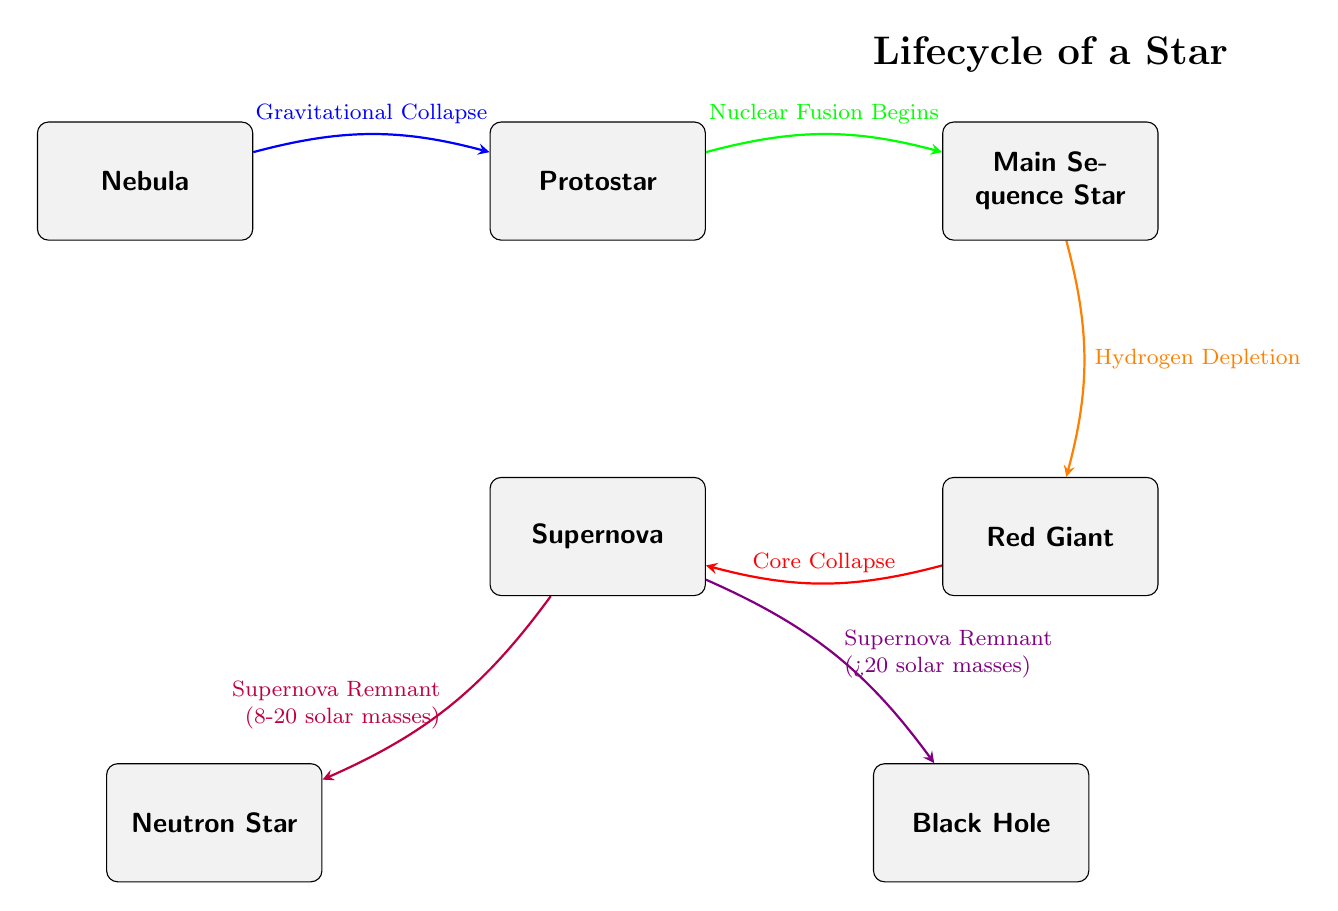What is the first stage in the lifecycle of a star? The diagram starts with the "Nebula" node, which is the initial stage of a star's lifecycle.
Answer: Nebula What process leads from the Protostar to the Main Sequence Star? According to the diagram, the transition from the "Protostar" to the "Main Sequence Star" is marked by the initiation of "Nuclear Fusion."
Answer: Nuclear Fusion Begins How many outcomes are there after the Supernova? From the "Supernova" node in the diagram, there are two possible outcomes: one leads to a "Neutron Star" and the other to a "Black Hole."
Answer: Two What leads to the formation of the Red Giant? The diagram indicates that "Hydrogen Depletion" is the process that leads to the formation of the "Red Giant" from the "Main Sequence Star."
Answer: Hydrogen Depletion What is the distinguishing factor for the formation of a Neutron Star versus a Black Hole? The diagram shows that the mass of the original star determines the outcome: for stars with 8-20 solar masses, the result is a "Neutron Star," and for those greater than 20 solar masses, it is a "Black Hole."
Answer: Mass Which node represents the final event in the life cycle of a star? The "Supernova" node is the final event that occurs during the lifecycle of a star before leading to either a "Neutron Star" or a "Black Hole."
Answer: Supernova What initiates the lifecycle of a star? The lifecycle of a star begins with the "Nebula," which is the starting point indicated in the diagram.
Answer: Nebula What happens immediately after a Red Giant? The "Red Giant" node transitions into the "Supernova" node, indicating that the next stage is the Supernova event.
Answer: Supernova 